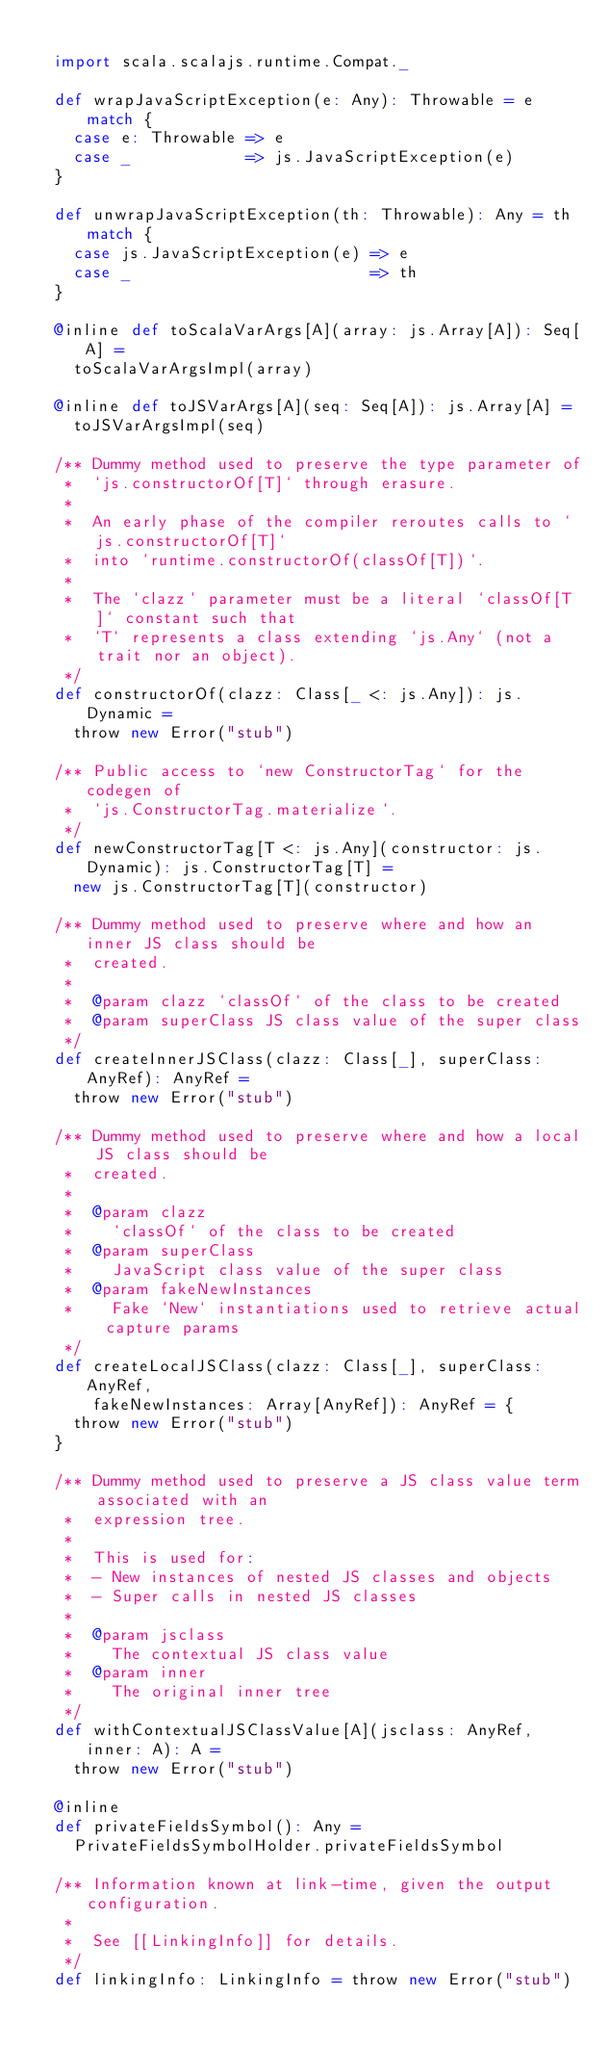Convert code to text. <code><loc_0><loc_0><loc_500><loc_500><_Scala_>
  import scala.scalajs.runtime.Compat._

  def wrapJavaScriptException(e: Any): Throwable = e match {
    case e: Throwable => e
    case _            => js.JavaScriptException(e)
  }

  def unwrapJavaScriptException(th: Throwable): Any = th match {
    case js.JavaScriptException(e) => e
    case _                         => th
  }

  @inline def toScalaVarArgs[A](array: js.Array[A]): Seq[A] =
    toScalaVarArgsImpl(array)

  @inline def toJSVarArgs[A](seq: Seq[A]): js.Array[A] =
    toJSVarArgsImpl(seq)

  /** Dummy method used to preserve the type parameter of
   *  `js.constructorOf[T]` through erasure.
   *
   *  An early phase of the compiler reroutes calls to `js.constructorOf[T]`
   *  into `runtime.constructorOf(classOf[T])`.
   *
   *  The `clazz` parameter must be a literal `classOf[T]` constant such that
   *  `T` represents a class extending `js.Any` (not a trait nor an object).
   */
  def constructorOf(clazz: Class[_ <: js.Any]): js.Dynamic =
    throw new Error("stub")

  /** Public access to `new ConstructorTag` for the codegen of
   *  `js.ConstructorTag.materialize`.
   */
  def newConstructorTag[T <: js.Any](constructor: js.Dynamic): js.ConstructorTag[T] =
    new js.ConstructorTag[T](constructor)

  /** Dummy method used to preserve where and how an inner JS class should be
   *  created.
   *
   *  @param clazz `classOf` of the class to be created
   *  @param superClass JS class value of the super class
   */
  def createInnerJSClass(clazz: Class[_], superClass: AnyRef): AnyRef =
    throw new Error("stub")

  /** Dummy method used to preserve where and how a local JS class should be
   *  created.
   *
   *  @param clazz
   *    `classOf` of the class to be created
   *  @param superClass
   *    JavaScript class value of the super class
   *  @param fakeNewInstances
   *    Fake `New` instantiations used to retrieve actual capture params
   */
  def createLocalJSClass(clazz: Class[_], superClass: AnyRef,
      fakeNewInstances: Array[AnyRef]): AnyRef = {
    throw new Error("stub")
  }

  /** Dummy method used to preserve a JS class value term associated with an
   *  expression tree.
   *
   *  This is used for:
   *  - New instances of nested JS classes and objects
   *  - Super calls in nested JS classes
   *
   *  @param jsclass
   *    The contextual JS class value
   *  @param inner
   *    The original inner tree
   */
  def withContextualJSClassValue[A](jsclass: AnyRef, inner: A): A =
    throw new Error("stub")

  @inline
  def privateFieldsSymbol(): Any =
    PrivateFieldsSymbolHolder.privateFieldsSymbol

  /** Information known at link-time, given the output configuration.
   *
   *  See [[LinkingInfo]] for details.
   */
  def linkingInfo: LinkingInfo = throw new Error("stub")
</code> 